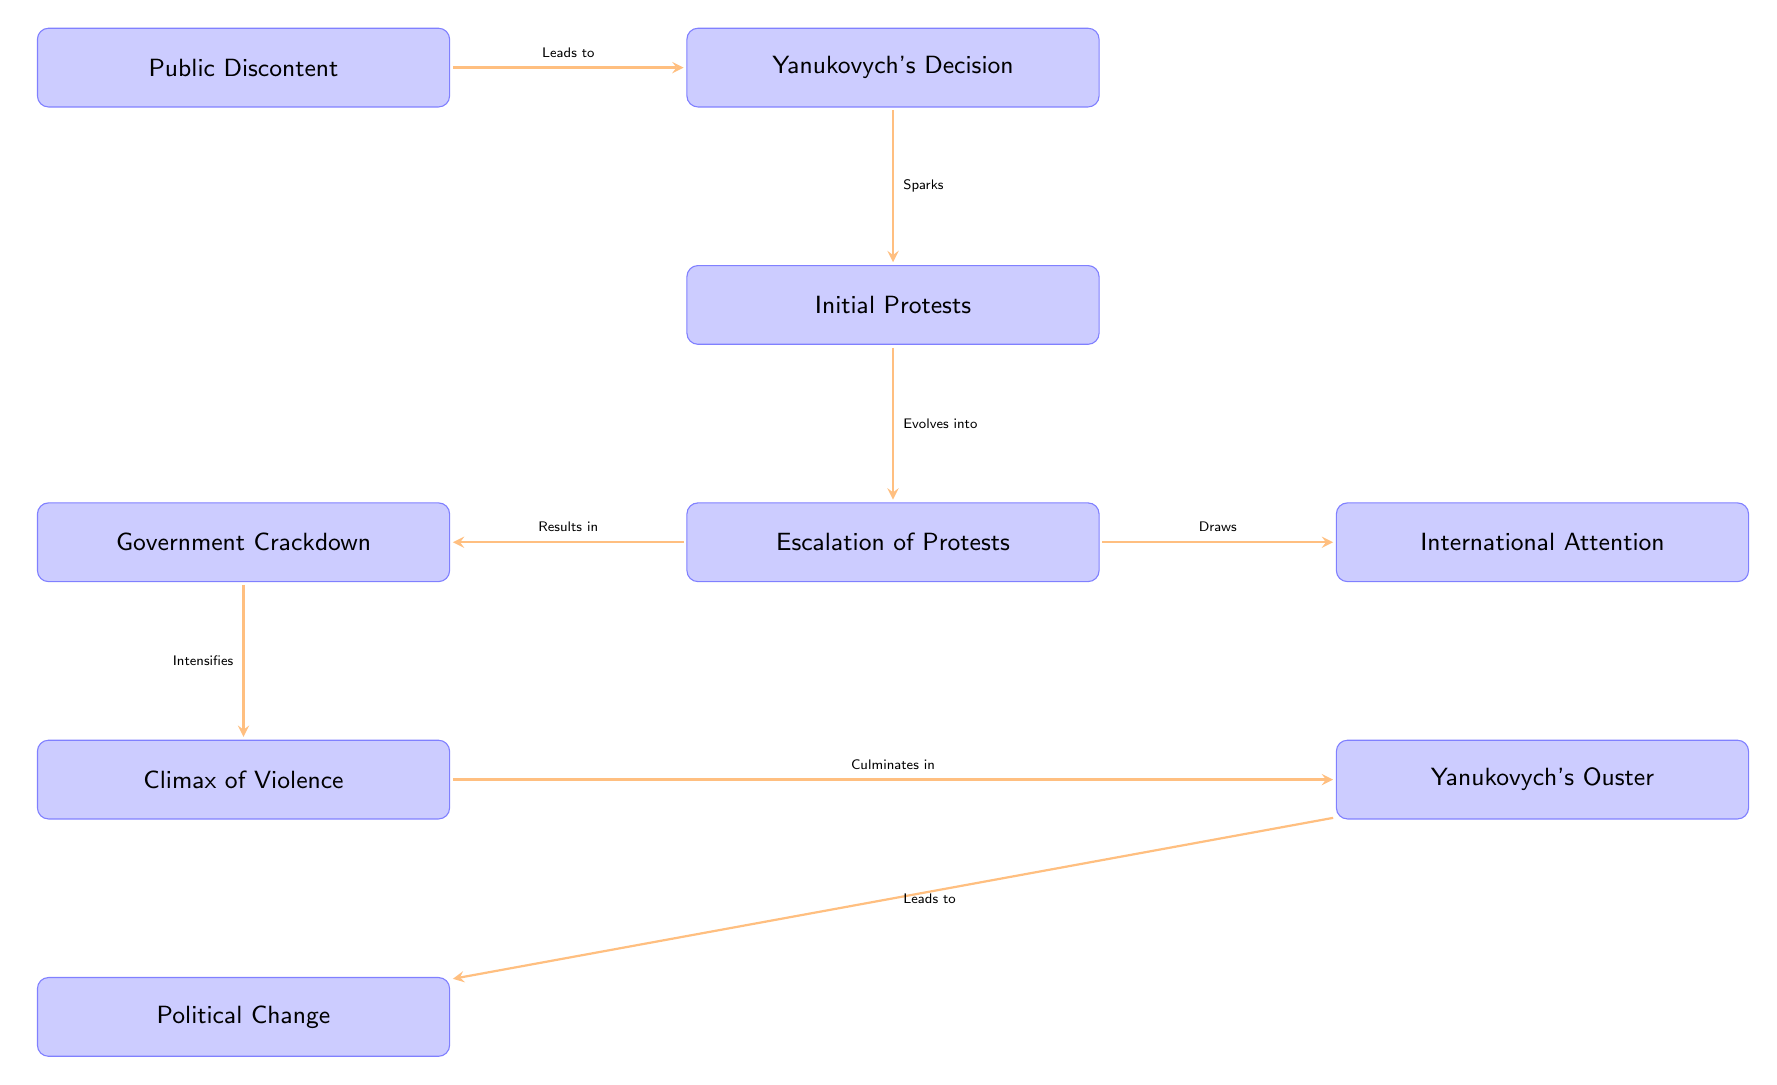What is the starting point of the diagram? The starting point is "Public Discontent," as it is the first node in the flow chart that initiates the sequence of events.
Answer: Public Discontent How many nodes are in the diagram? Counting all the nodes listed in the diagram, there are ten distinct nodes representing different events or factors in the Euromaidan protests.
Answer: 10 What event follows Yanukovych's Decision? Following "Yanukovych's Decision," according to the flow, the subsequent event is "Initial Protests," which sparks from the decision to suspend the EU agreement talks.
Answer: Initial Protests What event culminates in Yanukovych's Ouster? The event that culminates in "Yanukovych's Ouster" is identified as the "Climax of Violence," which contains the peak of unrest and leads directly to his ouster.
Answer: Climax of Violence What does the "Government Crackdown" result in? The "Government Crackdown" results in two outcomes: it intensifies the "Climax of Violence" and is located to the left of the "Escalation of Protests," which shows the aftermath of the government's repressive measures.
Answer: Climax of Violence How does the "Escalation of Protests" influence international factors? The "Escalation of Protests" draws "International Attention," indicating that as protests intensified, they garnered responses from outside Ukraine, particularly concerning the use of violence.
Answer: International Attention What leads to political change after Yanukovych's ouster? The event that leads to "Political Change" is "Yanukovych's Ouster," indicating that the action of removing him from power directly paves the way for subsequent political reforms and changes in governance.
Answer: Yanukovych's Ouster Which protest event had the most violence? The event recognized for having the most violence is "Climax of Violence," which is specifically noted for resulting in over 100 deaths known as the "Heavenly Hundred."
Answer: Climax of Violence Who took prominent roles in the response to the protests? The key opposition figures who took prominent roles are listed under "Politicians' Response," including Vitali Klitschko, Arseniy Yatsenyuk, and Oleh Tyahnybok.
Answer: Key opposition figures 